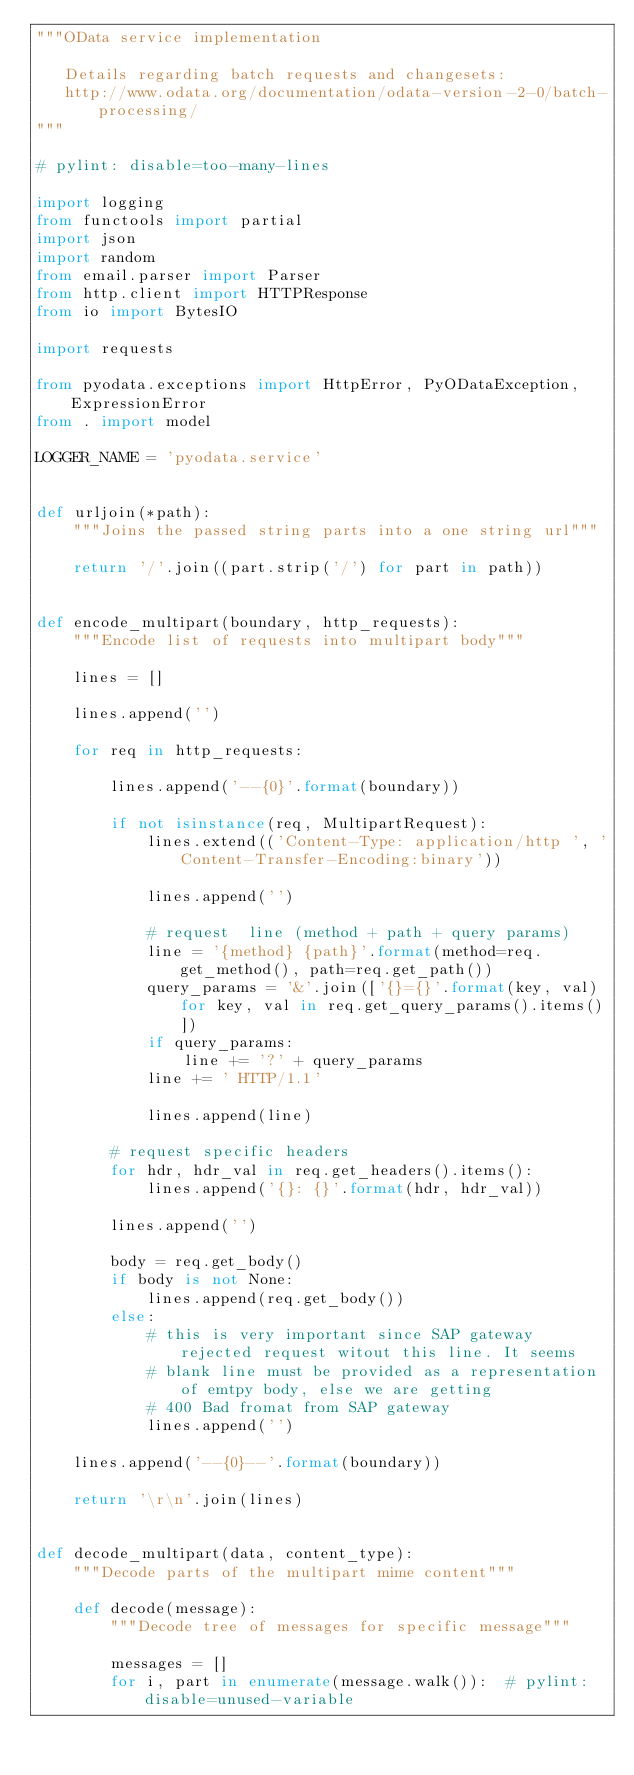<code> <loc_0><loc_0><loc_500><loc_500><_Python_>"""OData service implementation

   Details regarding batch requests and changesets:
   http://www.odata.org/documentation/odata-version-2-0/batch-processing/
"""

# pylint: disable=too-many-lines

import logging
from functools import partial
import json
import random
from email.parser import Parser
from http.client import HTTPResponse
from io import BytesIO

import requests

from pyodata.exceptions import HttpError, PyODataException, ExpressionError
from . import model

LOGGER_NAME = 'pyodata.service'


def urljoin(*path):
    """Joins the passed string parts into a one string url"""

    return '/'.join((part.strip('/') for part in path))


def encode_multipart(boundary, http_requests):
    """Encode list of requests into multipart body"""

    lines = []

    lines.append('')

    for req in http_requests:

        lines.append('--{0}'.format(boundary))

        if not isinstance(req, MultipartRequest):
            lines.extend(('Content-Type: application/http ', 'Content-Transfer-Encoding:binary'))

            lines.append('')

            # request  line (method + path + query params)
            line = '{method} {path}'.format(method=req.get_method(), path=req.get_path())
            query_params = '&'.join(['{}={}'.format(key, val) for key, val in req.get_query_params().items()])
            if query_params:
                line += '?' + query_params
            line += ' HTTP/1.1'

            lines.append(line)

        # request specific headers
        for hdr, hdr_val in req.get_headers().items():
            lines.append('{}: {}'.format(hdr, hdr_val))

        lines.append('')

        body = req.get_body()
        if body is not None:
            lines.append(req.get_body())
        else:
            # this is very important since SAP gateway rejected request witout this line. It seems
            # blank line must be provided as a representation of emtpy body, else we are getting
            # 400 Bad fromat from SAP gateway
            lines.append('')

    lines.append('--{0}--'.format(boundary))

    return '\r\n'.join(lines)


def decode_multipart(data, content_type):
    """Decode parts of the multipart mime content"""

    def decode(message):
        """Decode tree of messages for specific message"""

        messages = []
        for i, part in enumerate(message.walk()):  # pylint: disable=unused-variable</code> 